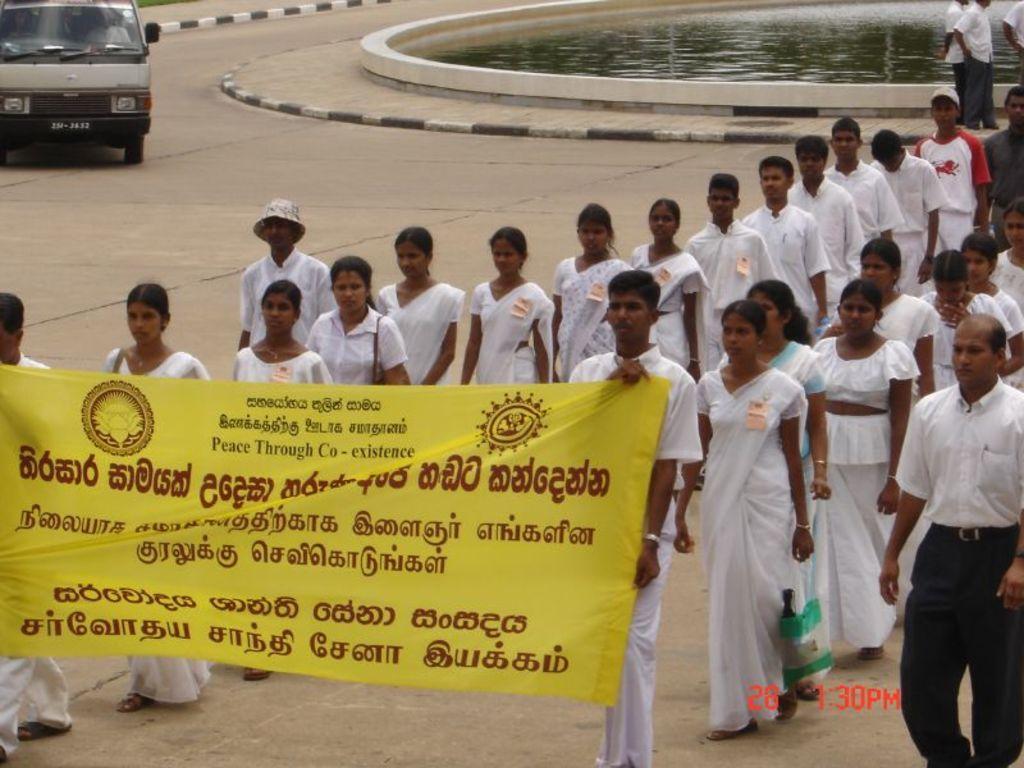Could you give a brief overview of what you see in this image? There are group of people walking on the road. I can see two people holding a banner and walking. This looks like a van, which is moving on the road. These are the water flowing. I can see the watermark on the image. 